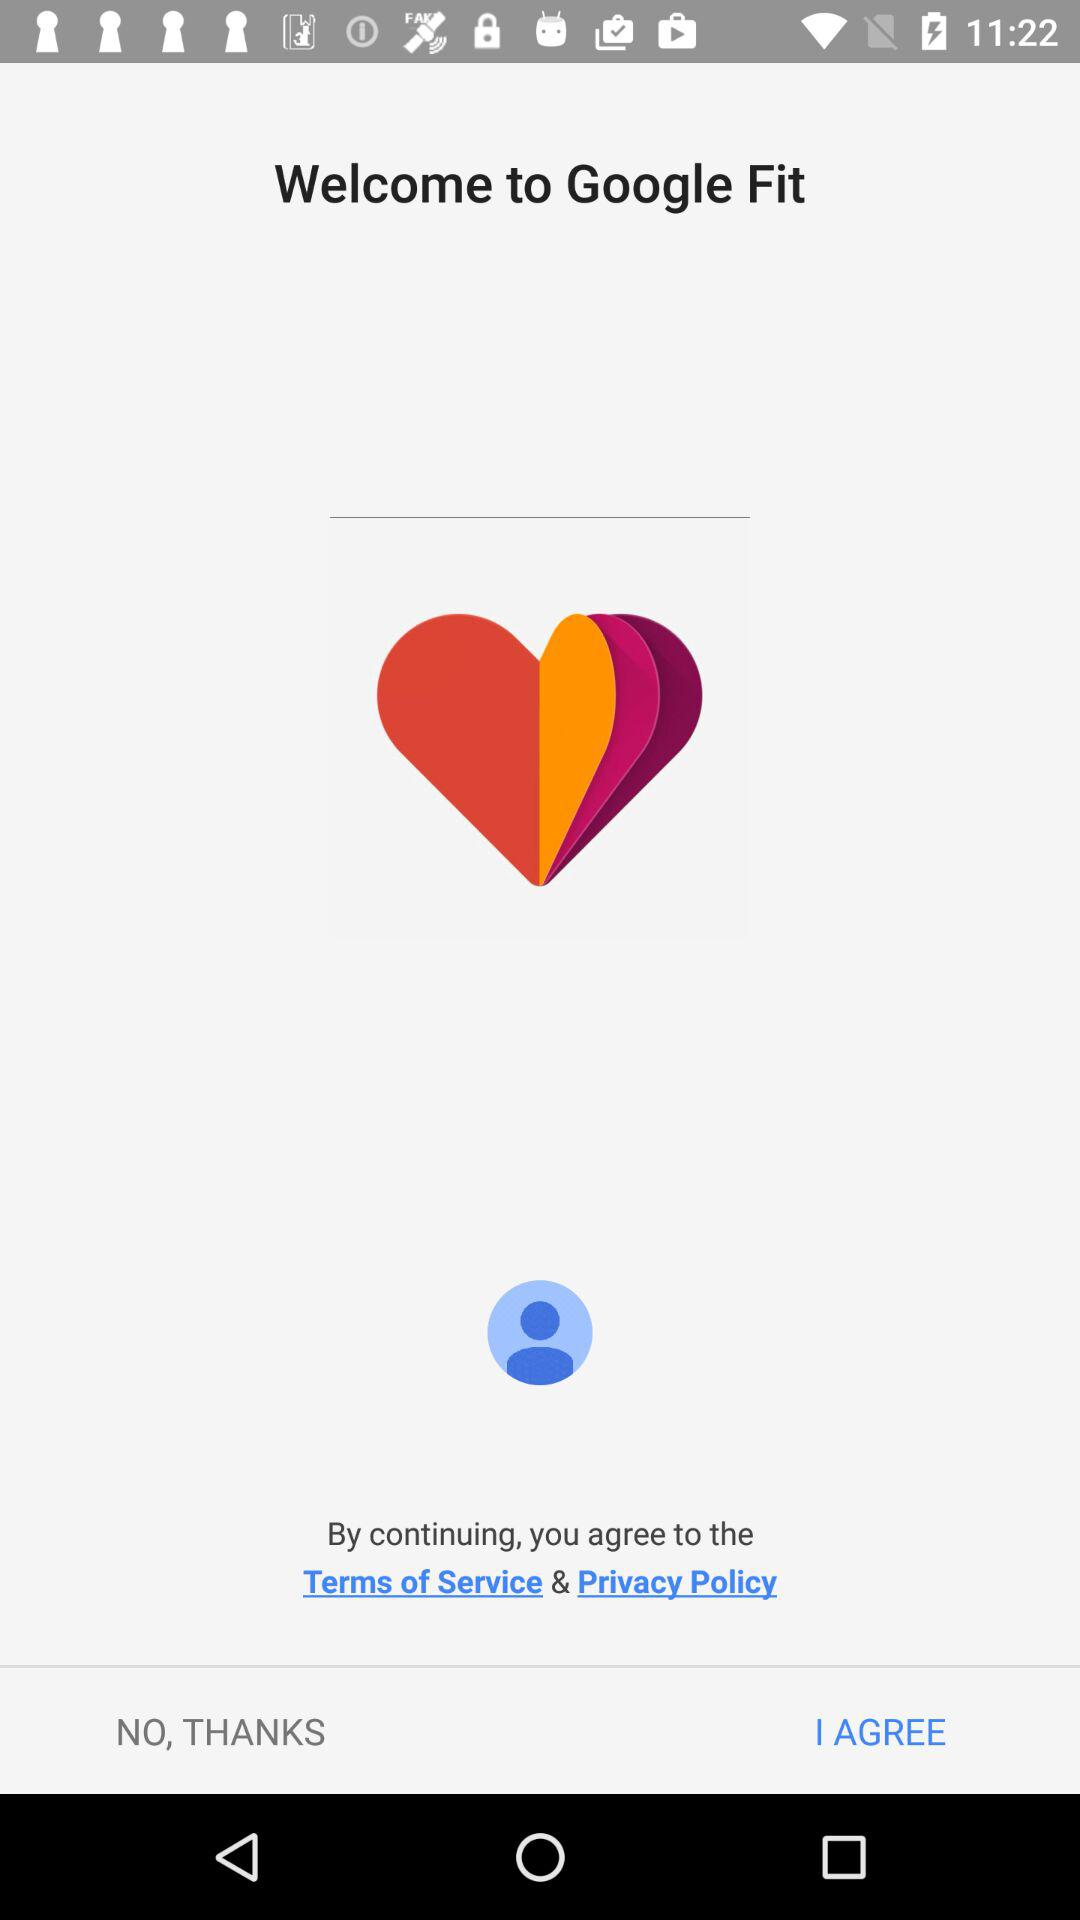What is the application name? The application name is "Google Fit". 